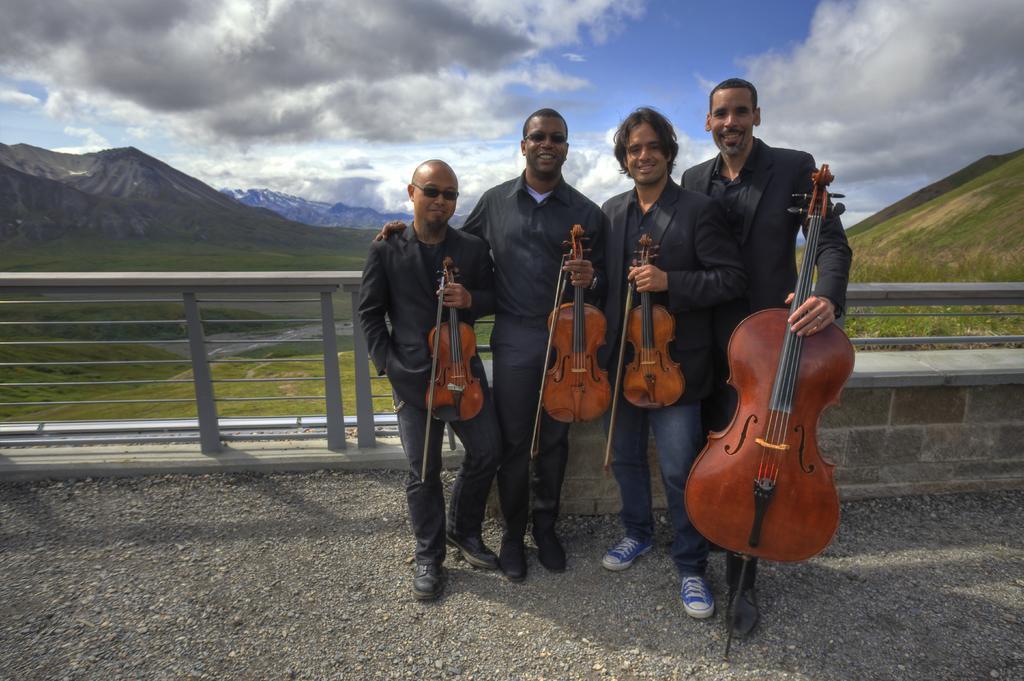Can you describe this image briefly? Completely an outdoor picture. Sky is cloudy. Far there are mountains. Front this persons are standing and holding a violin, which is in brown color. This persons wore black suit and black shirt and smiling. Backside of this person's there is fence. 